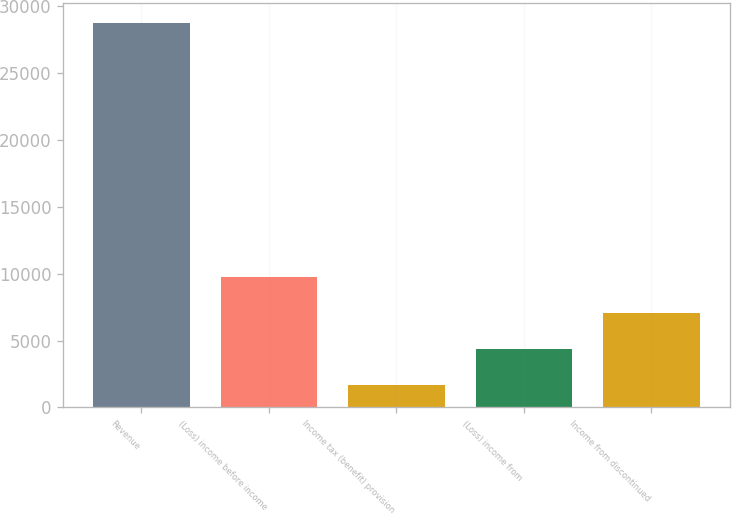Convert chart to OTSL. <chart><loc_0><loc_0><loc_500><loc_500><bar_chart><fcel>Revenue<fcel>(Loss) income before income<fcel>Income tax (benefit) provision<fcel>(Loss) income from<fcel>Income from discontinued<nl><fcel>28769<fcel>9784.3<fcel>1648<fcel>4360.1<fcel>7072.2<nl></chart> 